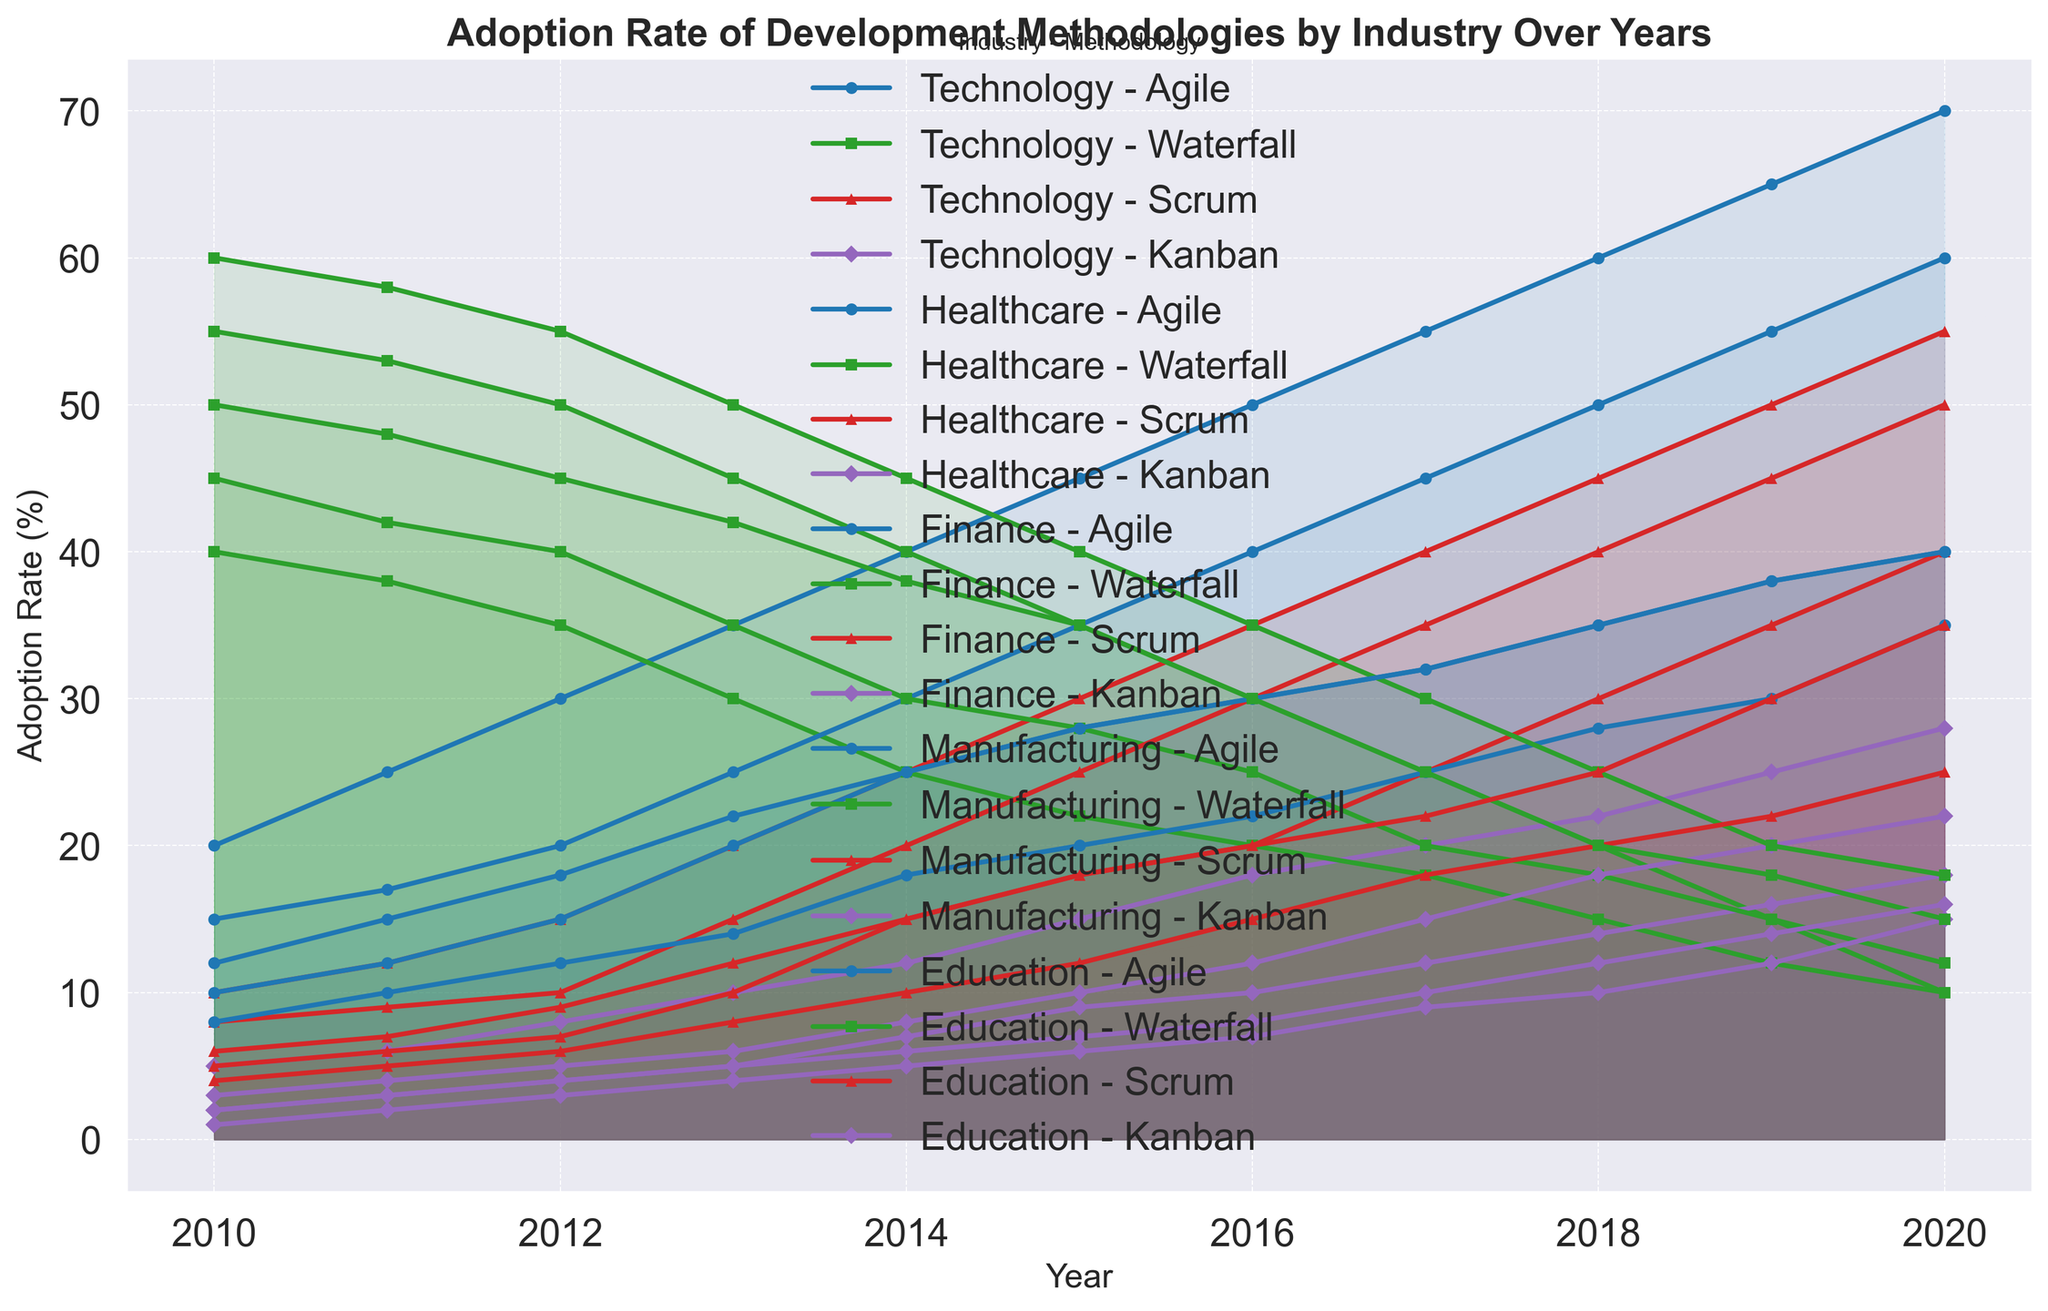Which industry had the highest adoption rate of Agile in 2020? Look at the dataset and see the data points for the year 2020 across industries for Agile. The highest value is 70% for Technology.
Answer: Technology How did the adoption of Kanban in Healthcare change from 2010 to 2020? Determine the data points for Kanban in Healthcare for the years 2010 and 2020. The adoption rate increased from 2% in 2010 to 18% in 2020.
Answer: Increased In 2015, did the Finance industry have a higher adoption rate of Scrum or Waterfall? Compare the adoption rates of Scrum and Waterfall in the Finance industry for 2015. Scrum is at 25% and Waterfall is at 28%; therefore, Waterfall is higher.
Answer: Waterfall Which year did the Technology industry surpass a 50% adoption rate of Agile for the first time? Review the adoption rates for Agile in the Technology industry across the years and identify that it surpassed 50% in 2016.
Answer: 2016 What is the average adoption rate of Agile across all industries in 2014? Sum the adoption rates of Agile for all industries in 2014, which gives 40 + 25 + 30 + 18 + 25 = 138. Then, divide by the number of industries (5).
Answer: 27.6 How does the adoption of Waterfall in Manufacturing in 2020 compare to that in 2010? Compare the data points for Waterfall in Manufacturing for the years 2010 and 2020, showing a decrease from 60% to 18%.
Answer: Decreased Which methodology had the least increase in adoption in Technology from 2010 to 2020? Compare the increases for each methodology in Technology from 2010 to 2020. Kanban increased from 5% to 28%, Scrum from 10% to 55%, Waterfall decreased, and Agile increased from 20% to 70%. The smallest increase is for Kanban.
Answer: Kanban What was the trend of Waterfall adoption rate in the Education industry from 2010 to 2020? Look at the dataset for the Waterfall values in the Education industry over the years. The trend shows a consistent decline from 55% in 2010 to 15% in 2020.
Answer: Decline Which industry showed the largest increase in Scrum adoption between 2010 and 2020? Calculate the difference in Scrum adoption rates from 2010 to 2020 for each industry. Healthcare increased from 5% to 40%, Finance from 8% to 50%, Manufacturing from 4% to 25%, and Education from 6% to 35%. Finance showed the largest increase.
Answer: Finance 